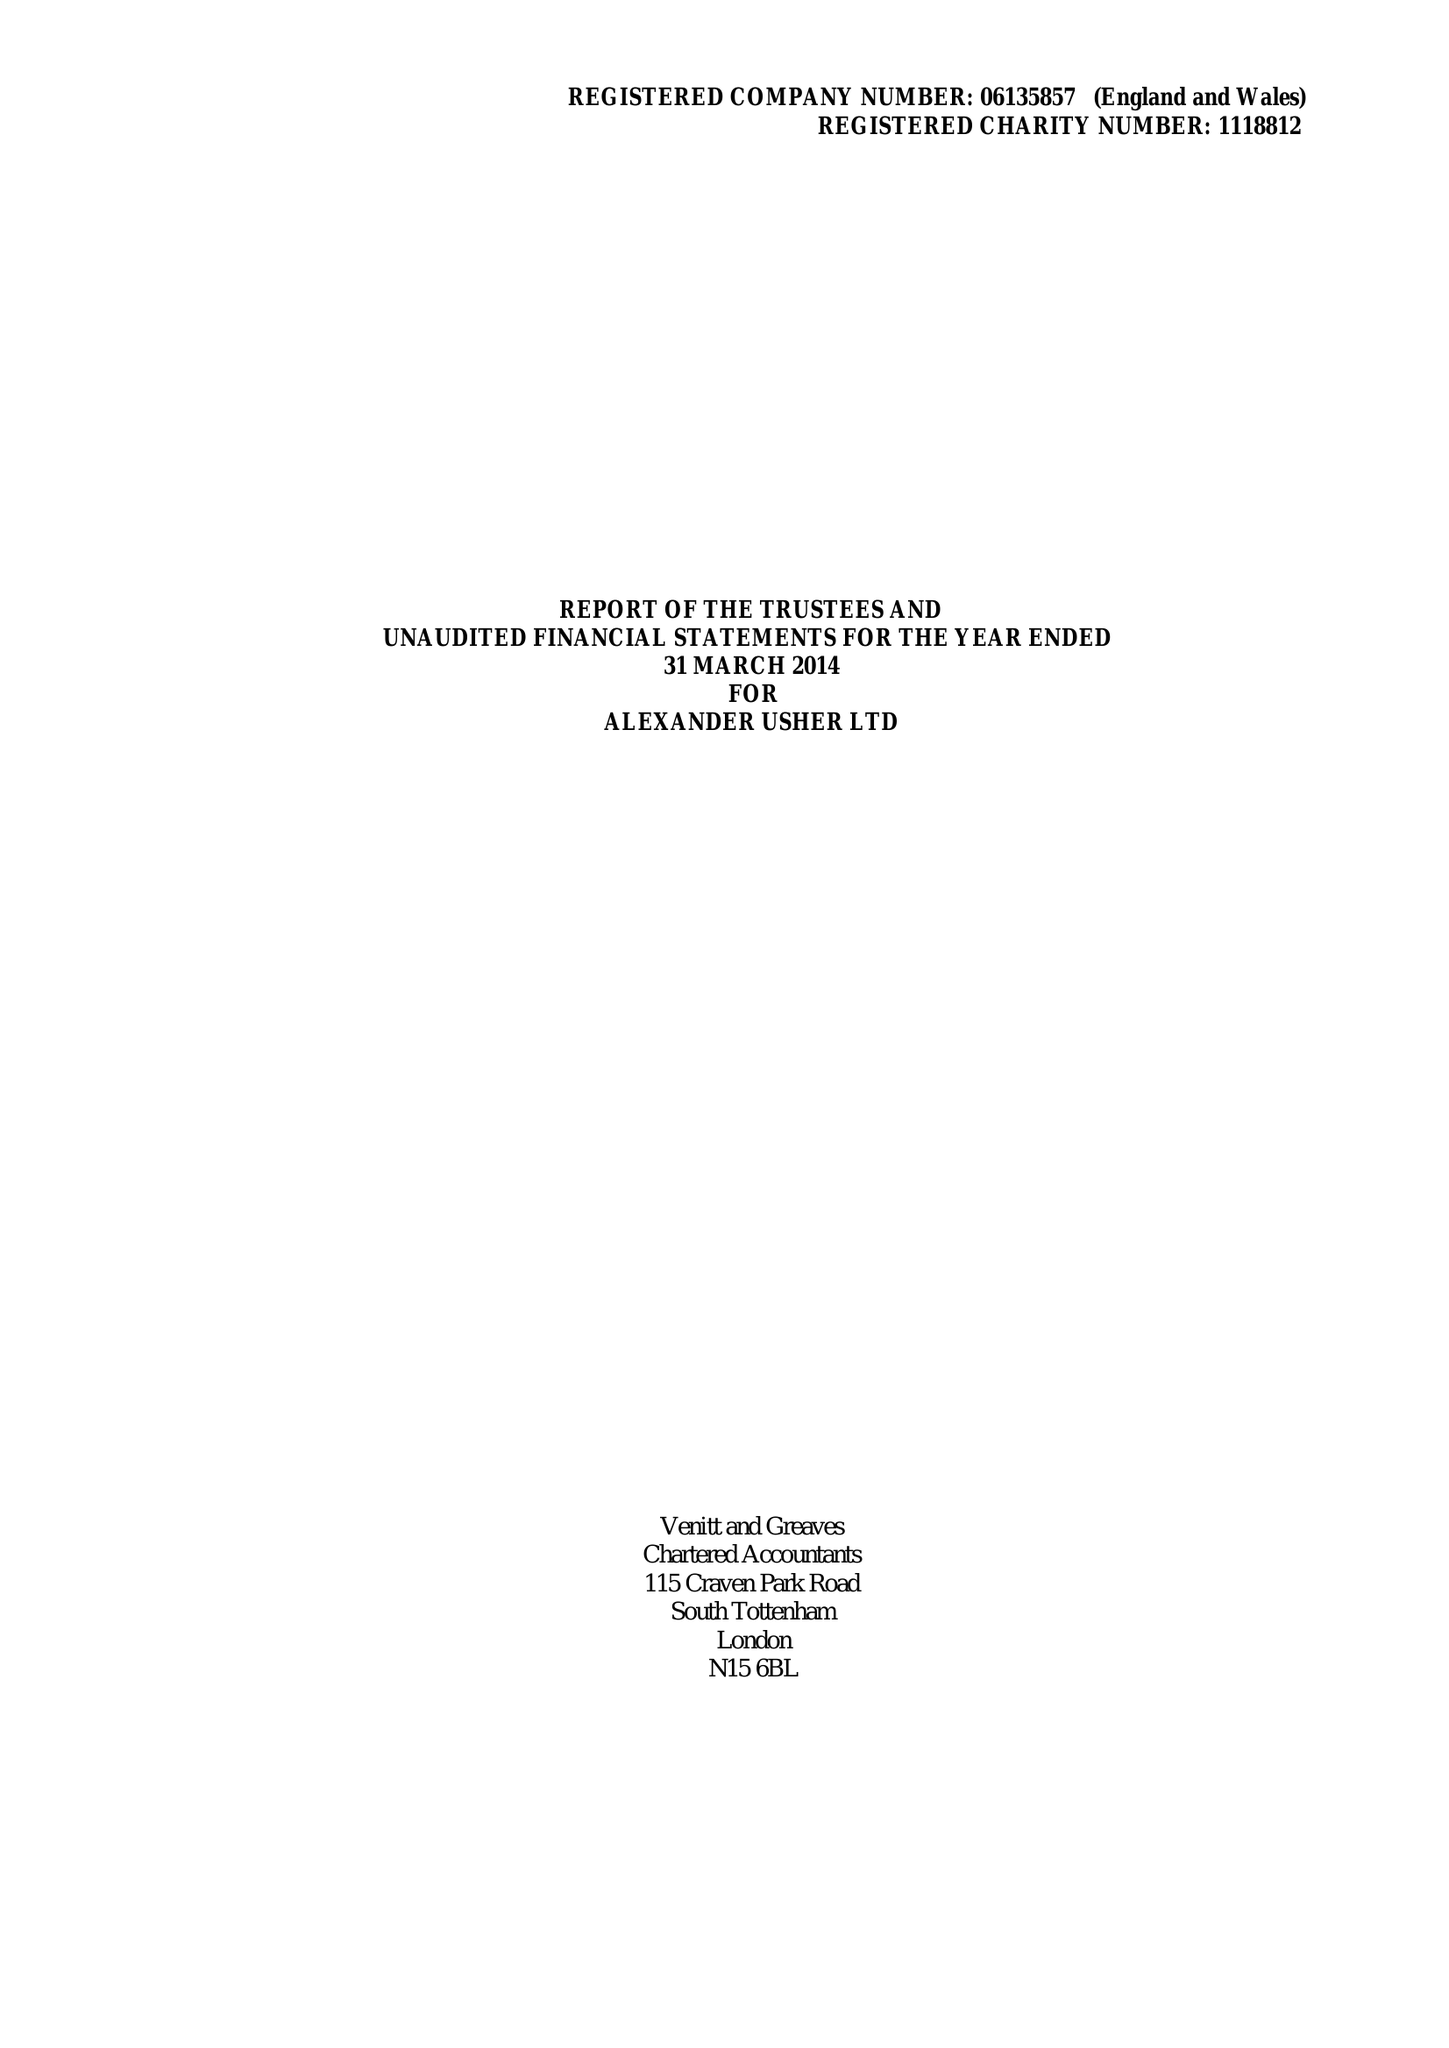What is the value for the charity_name?
Answer the question using a single word or phrase. Alexander Usher Ltd. 